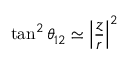<formula> <loc_0><loc_0><loc_500><loc_500>\tan ^ { 2 } \theta _ { 1 2 } \simeq \left | \frac { z } { r } \right | ^ { 2 }</formula> 